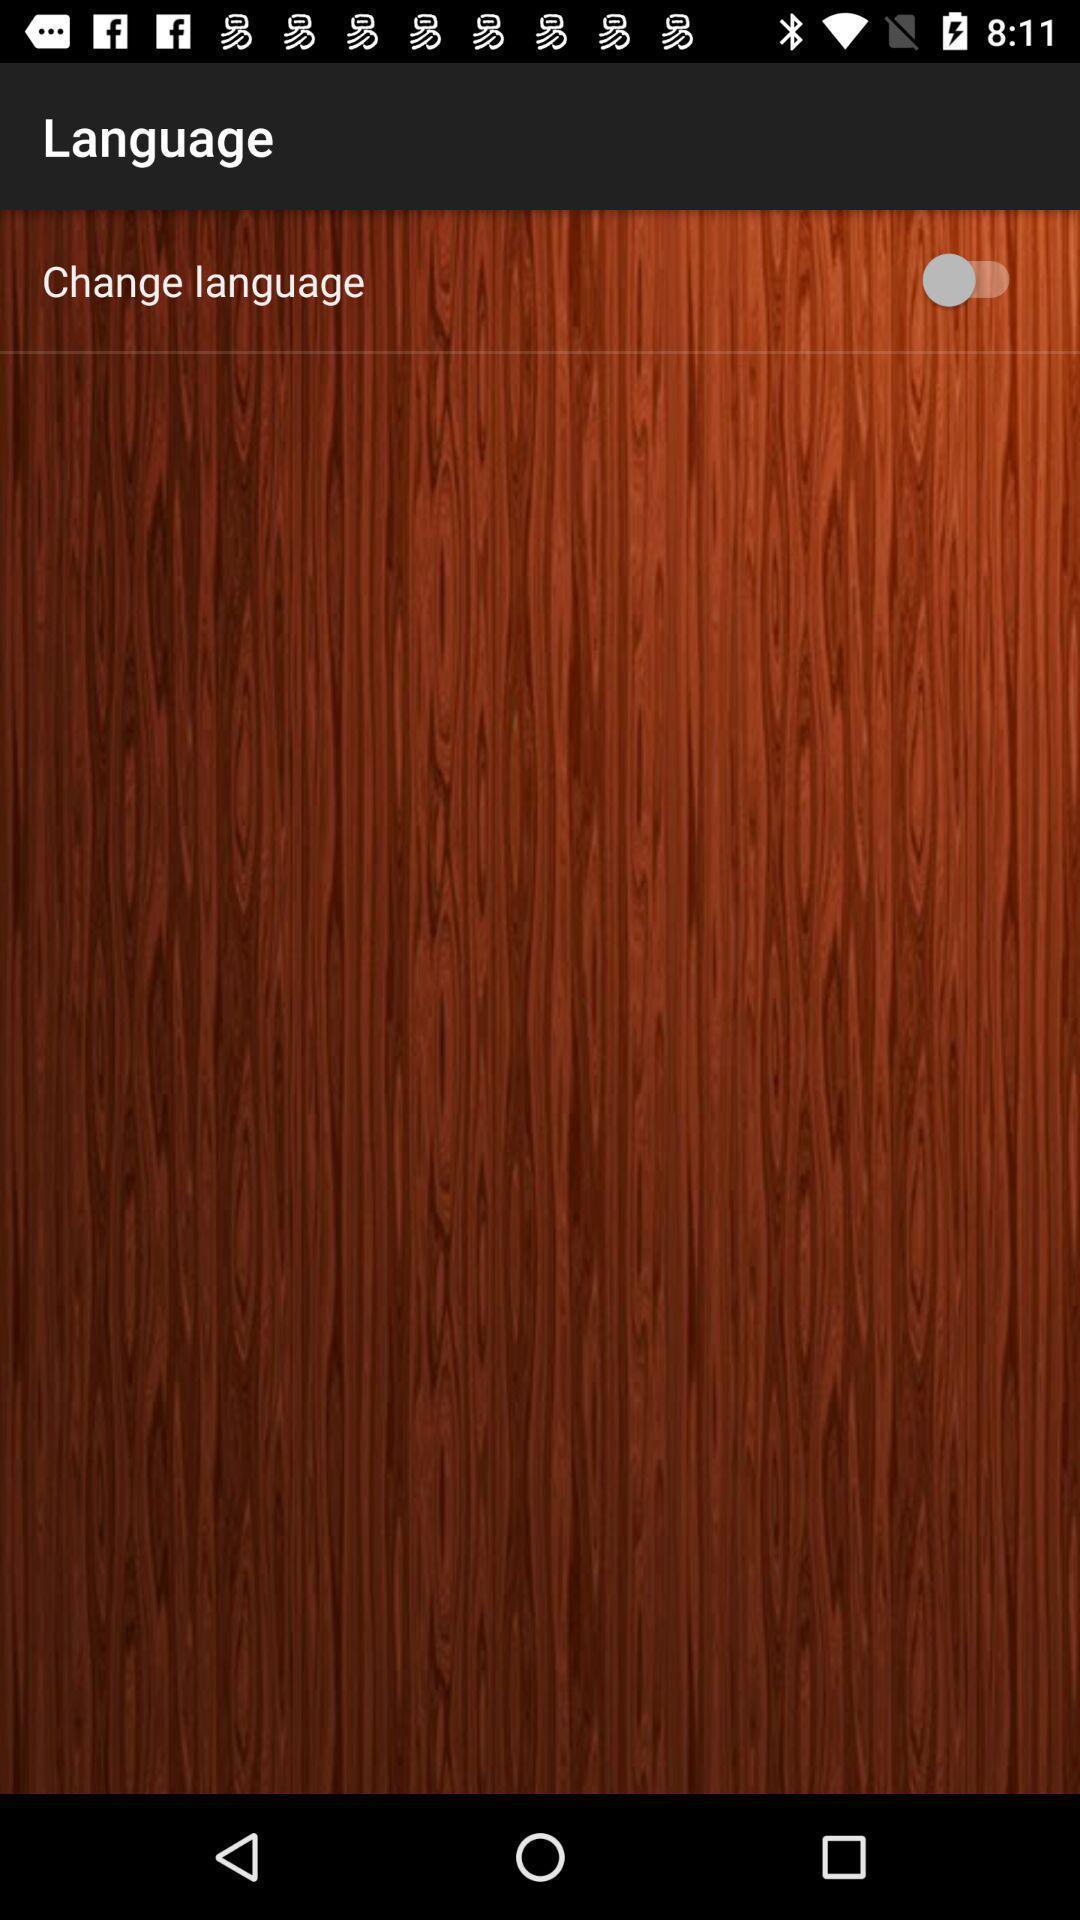What details can you identify in this image? Page showing option like change language. 